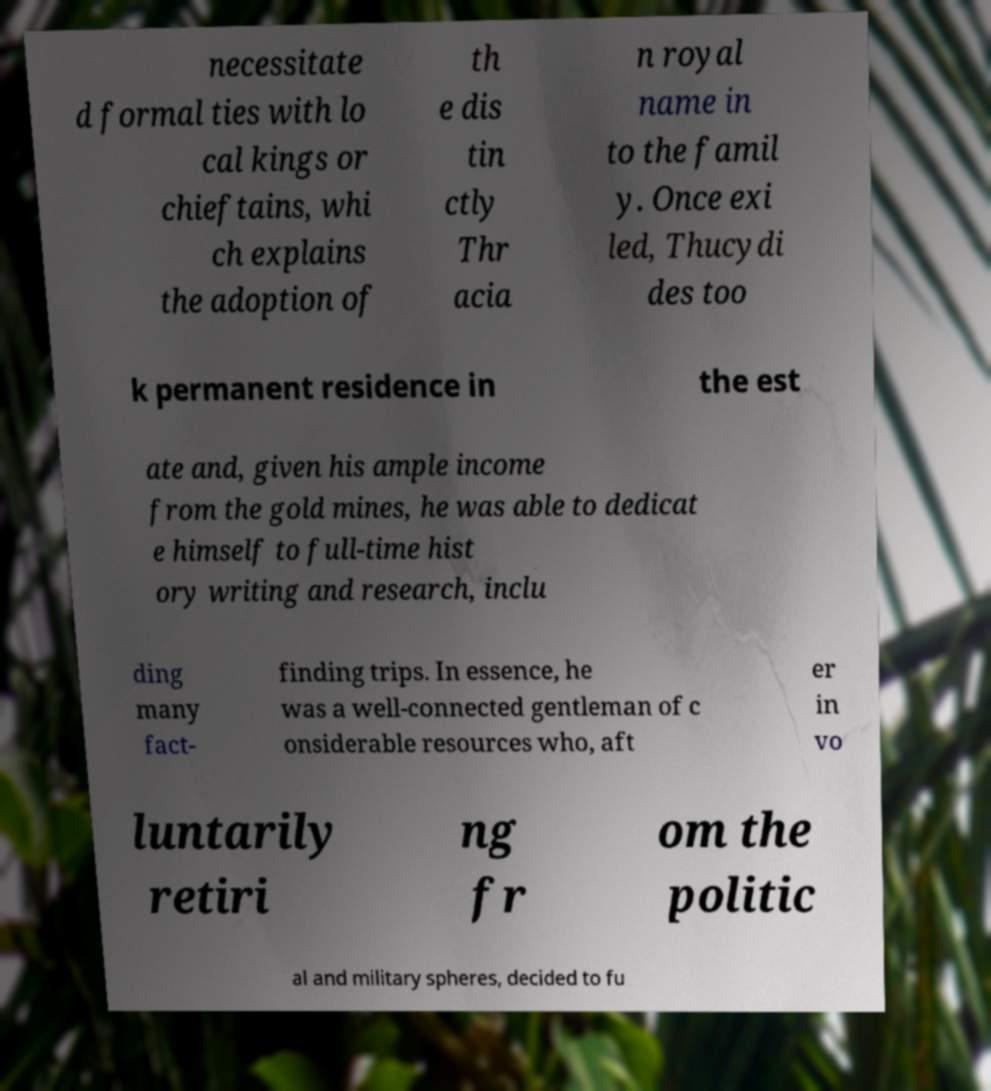Please read and relay the text visible in this image. What does it say? necessitate d formal ties with lo cal kings or chieftains, whi ch explains the adoption of th e dis tin ctly Thr acia n royal name in to the famil y. Once exi led, Thucydi des too k permanent residence in the est ate and, given his ample income from the gold mines, he was able to dedicat e himself to full-time hist ory writing and research, inclu ding many fact- finding trips. In essence, he was a well-connected gentleman of c onsiderable resources who, aft er in vo luntarily retiri ng fr om the politic al and military spheres, decided to fu 